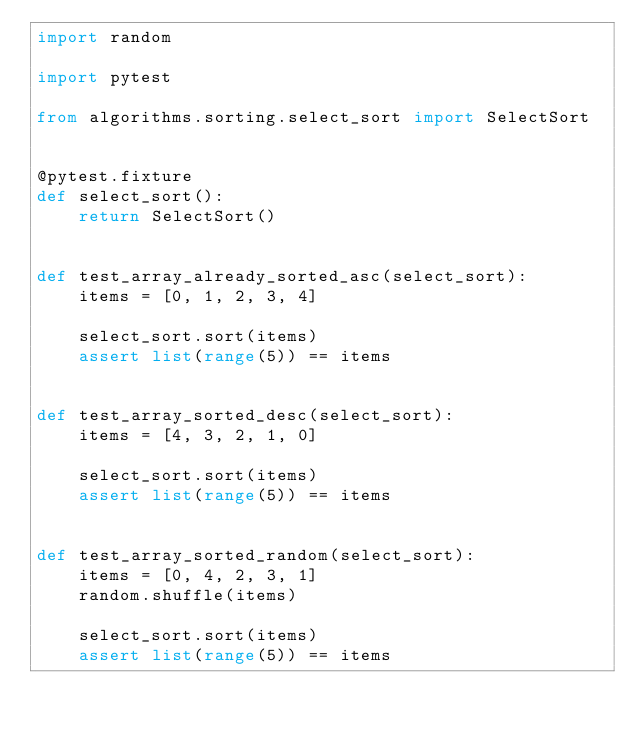Convert code to text. <code><loc_0><loc_0><loc_500><loc_500><_Python_>import random

import pytest

from algorithms.sorting.select_sort import SelectSort


@pytest.fixture
def select_sort():
    return SelectSort()


def test_array_already_sorted_asc(select_sort):
    items = [0, 1, 2, 3, 4]

    select_sort.sort(items)
    assert list(range(5)) == items


def test_array_sorted_desc(select_sort):
    items = [4, 3, 2, 1, 0]

    select_sort.sort(items)
    assert list(range(5)) == items


def test_array_sorted_random(select_sort):
    items = [0, 4, 2, 3, 1]
    random.shuffle(items)

    select_sort.sort(items)
    assert list(range(5)) == items
</code> 